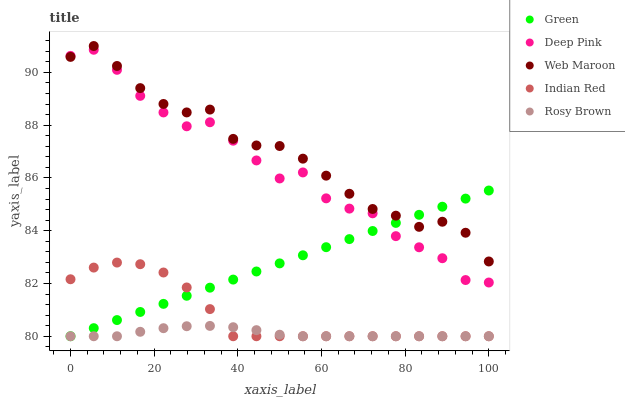Does Rosy Brown have the minimum area under the curve?
Answer yes or no. Yes. Does Web Maroon have the maximum area under the curve?
Answer yes or no. Yes. Does Deep Pink have the minimum area under the curve?
Answer yes or no. No. Does Deep Pink have the maximum area under the curve?
Answer yes or no. No. Is Green the smoothest?
Answer yes or no. Yes. Is Deep Pink the roughest?
Answer yes or no. Yes. Is Rosy Brown the smoothest?
Answer yes or no. No. Is Rosy Brown the roughest?
Answer yes or no. No. Does Rosy Brown have the lowest value?
Answer yes or no. Yes. Does Deep Pink have the lowest value?
Answer yes or no. No. Does Web Maroon have the highest value?
Answer yes or no. Yes. Does Deep Pink have the highest value?
Answer yes or no. No. Is Indian Red less than Deep Pink?
Answer yes or no. Yes. Is Web Maroon greater than Rosy Brown?
Answer yes or no. Yes. Does Web Maroon intersect Deep Pink?
Answer yes or no. Yes. Is Web Maroon less than Deep Pink?
Answer yes or no. No. Is Web Maroon greater than Deep Pink?
Answer yes or no. No. Does Indian Red intersect Deep Pink?
Answer yes or no. No. 